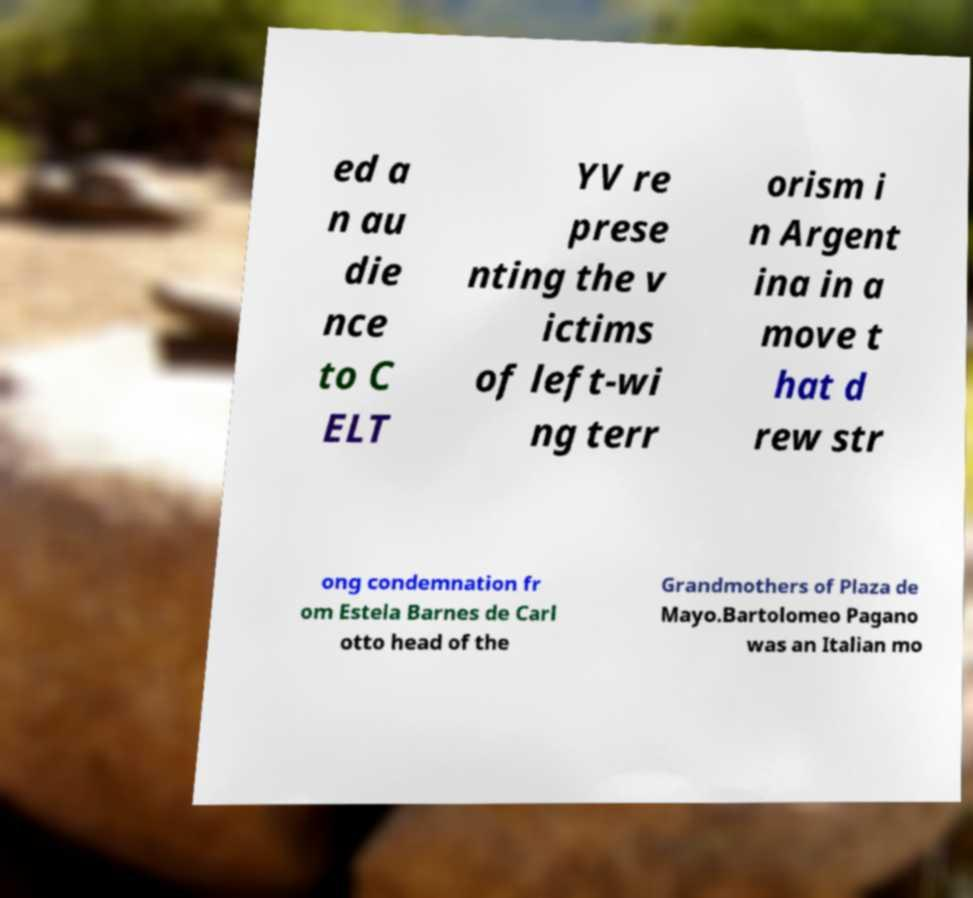There's text embedded in this image that I need extracted. Can you transcribe it verbatim? ed a n au die nce to C ELT YV re prese nting the v ictims of left-wi ng terr orism i n Argent ina in a move t hat d rew str ong condemnation fr om Estela Barnes de Carl otto head of the Grandmothers of Plaza de Mayo.Bartolomeo Pagano was an Italian mo 